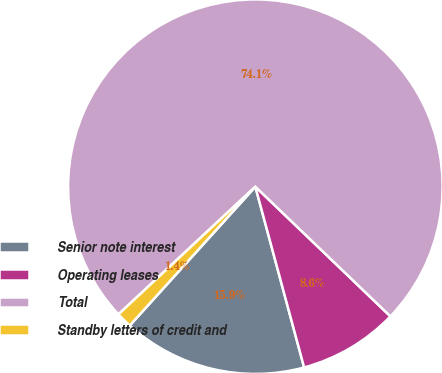Convert chart to OTSL. <chart><loc_0><loc_0><loc_500><loc_500><pie_chart><fcel>Senior note interest<fcel>Operating leases<fcel>Total<fcel>Standby letters of credit and<nl><fcel>15.9%<fcel>8.63%<fcel>74.12%<fcel>1.35%<nl></chart> 